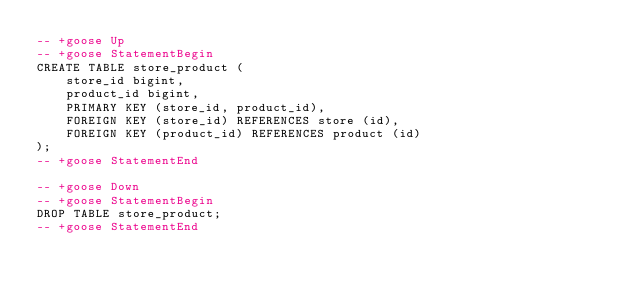Convert code to text. <code><loc_0><loc_0><loc_500><loc_500><_SQL_>-- +goose Up
-- +goose StatementBegin
CREATE TABLE store_product (
    store_id bigint,
    product_id bigint,
    PRIMARY KEY (store_id, product_id),
    FOREIGN KEY (store_id) REFERENCES store (id),
    FOREIGN KEY (product_id) REFERENCES product (id)
);
-- +goose StatementEnd

-- +goose Down
-- +goose StatementBegin
DROP TABLE store_product;
-- +goose StatementEnd
</code> 